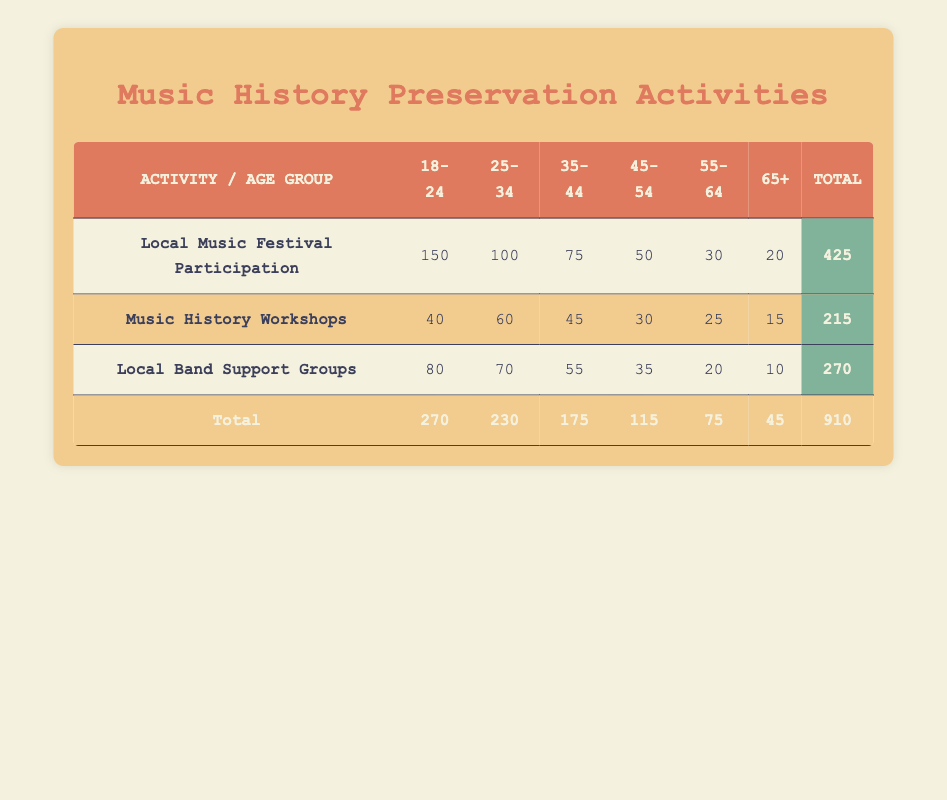What is the total participation count for the "Local Music Festival Participation" activity? To find the total participation count for this activity, we can refer to the respective row in the table. The count values in that row are 150, 100, 75, 50, 30, and 20 for age groups 18-24, 25-34, 35-44, 45-54, 55-64, and 65+, respectively. Adding these values together gives us: 150 + 100 + 75 + 50 + 30 + 20 = 425.
Answer: 425 Which activity has the highest participation count for age group 18-24? Looking at the count for age group 18-24 across all activities, we see 150 for Local Music Festival Participation, 40 for Music History Workshops, and 80 for Local Band Support Groups. The highest count among these values is 150 for Local Music Festival Participation.
Answer: Local Music Festival Participation What is the average participation count for the "Music History Workshops" activity across all age groups? The count values for Music History Workshops are 40, 60, 45, 30, 25, and 15 for the respective age groups. First, we sum these counts: 40 + 60 + 45 + 30 + 25 + 15 = 215. There are 6 age groups, so we divide the total count by 6 to find the average: 215 / 6 = 35.8333, which rounds to approximately 36.
Answer: 36 Is the total number of participants for the "Local Band Support Groups" higher than 300? To determine this, we need to find the total count for Local Band Support Groups from the table. The counts for this activity are 80, 70, 55, 35, 20, and 10. Summing these counts gives us: 80 + 70 + 55 + 35 + 20 + 10 = 270, which is less than 300. Therefore, the answer is no.
Answer: No What is the difference in participation count between age group 45-54 and age group 65+ for the "Local Music Festival Participation"? We start by retrieving the counts for both age groups from the table for Local Music Festival Participation. The count for age group 45-54 is 50, and for age group 65+, it is 20. We then find the difference by subtracting the count of 65+ from that of 45-54: 50 - 20 = 30.
Answer: 30 Which age group has the least participants in the "Music History Workshops"? We look at the count values for Music History Workshops across all age groups: 40, 60, 45, 30, 25, and 15. The least participation count is 15, which corresponds to the age group 65+.
Answer: 65+ Are more people participating in "Local Music Festival Participation" than in "Local Band Support Groups"? First, we compare the total counts for both activities: Local Music Festival Participation has 425 participants, while Local Band Support Groups has 270 participants. Since 425 is greater than 270, the answer is yes.
Answer: Yes What is the total participation in activities for age group 55-64? To find this total, we need to look at each activity's count for age group 55-64, which are 30 for Local Music Festival Participation, 25 for Music History Workshops, and 20 for Local Band Support Groups. Adding these together gives 30 + 25 + 20 = 75.
Answer: 75 How does the total participation of the age group 25-34 compare to that of the age group 45-54 across all activities? The total participation for age group 25-34 is calculated by adding counts for each activity: 100 for Local Music Festival Participation, 60 for Music History Workshops, and 70 for Local Band Support Groups, giving a total of 100 + 60 + 70 = 230. For age group 45-54, the counts are 50 (Local Music Festival Participation) + 30 (Music History Workshops) + 35 (Local Band Support Groups), totaling 50 + 30 + 35 = 115. Since 230 is greater than 115, age group 25-34 has higher participation.
Answer: Age group 25-34 has higher participation 